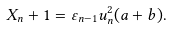Convert formula to latex. <formula><loc_0><loc_0><loc_500><loc_500>X _ { n } + 1 = \varepsilon _ { n - 1 } u _ { n } ^ { 2 } ( a + b ) .</formula> 